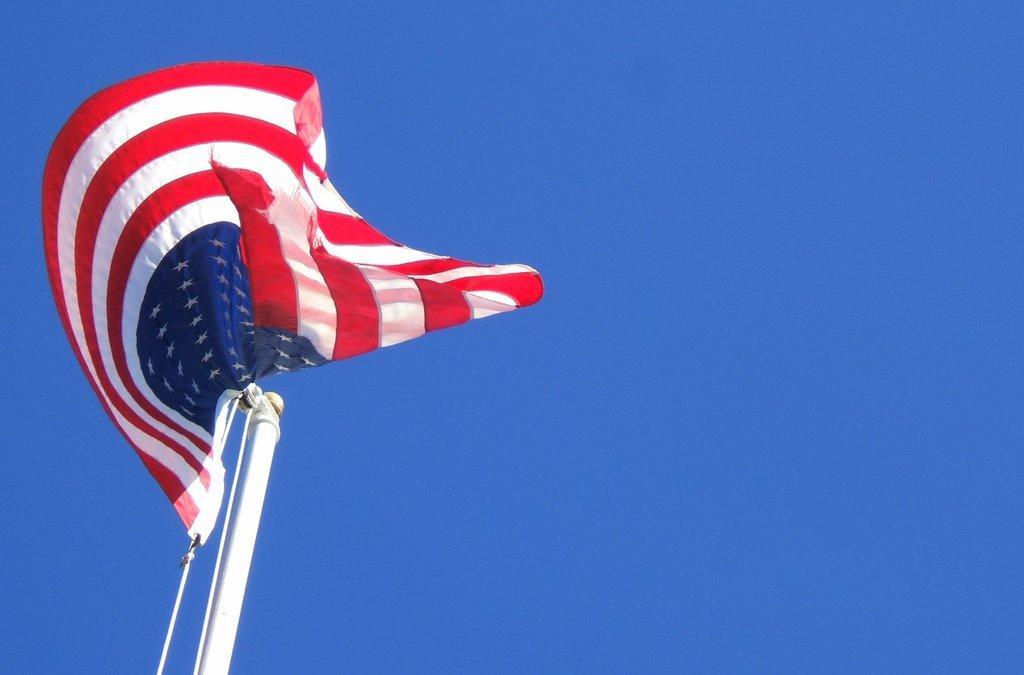Describe this image in one or two sentences. In this image, I can see a flag and a rope are hanging to a pole. In the background, there is the sky. 